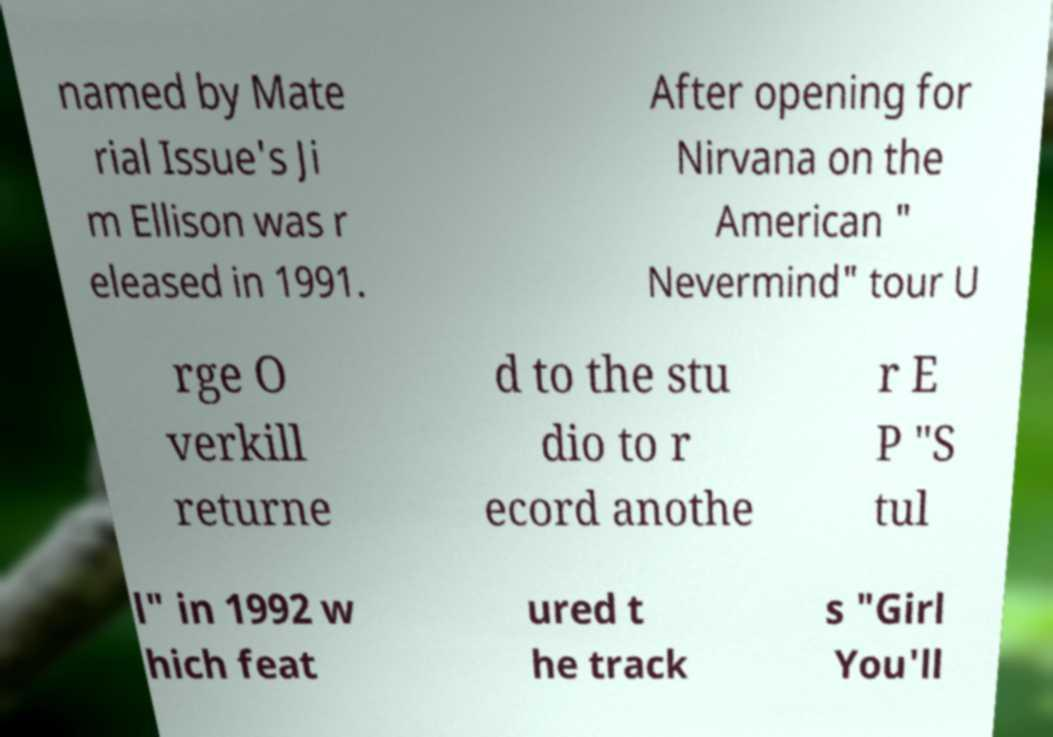Could you assist in decoding the text presented in this image and type it out clearly? named by Mate rial Issue's Ji m Ellison was r eleased in 1991. After opening for Nirvana on the American " Nevermind" tour U rge O verkill returne d to the stu dio to r ecord anothe r E P "S tul l" in 1992 w hich feat ured t he track s "Girl You'll 